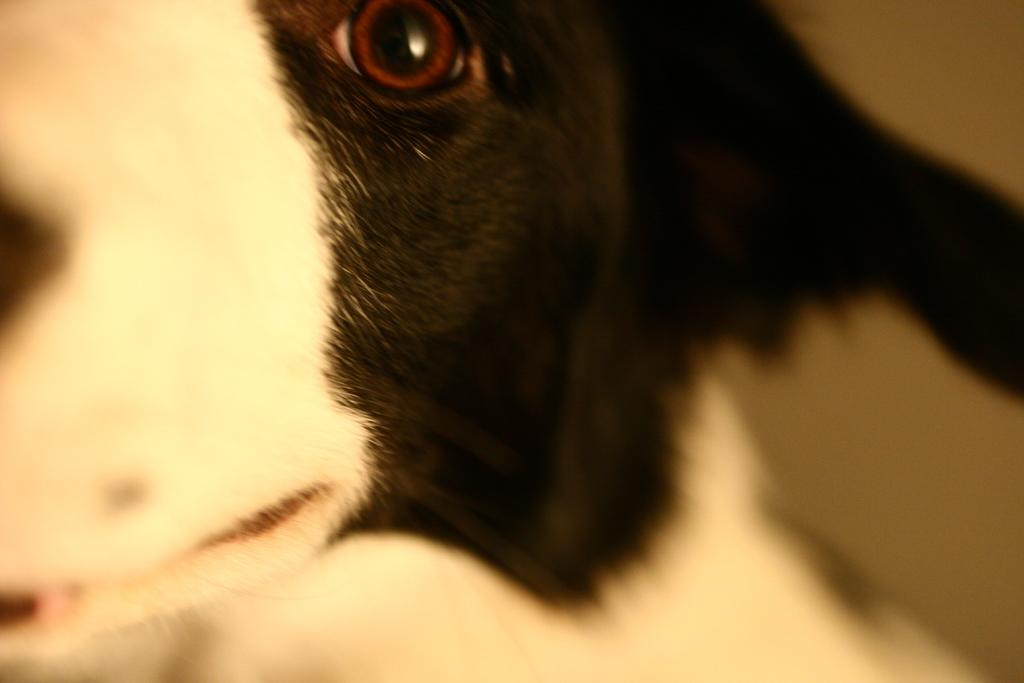What type of animal is present in the image? There is a dog in the image. What type of cabbage is the dog holding in the image? There is no cabbage present in the image; it features a dog. What type of silk material is draped over the dog in the image? There is no silk material present in the image; it features a dog. 